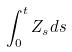<formula> <loc_0><loc_0><loc_500><loc_500>\int _ { 0 } ^ { t } Z _ { s } d s</formula> 